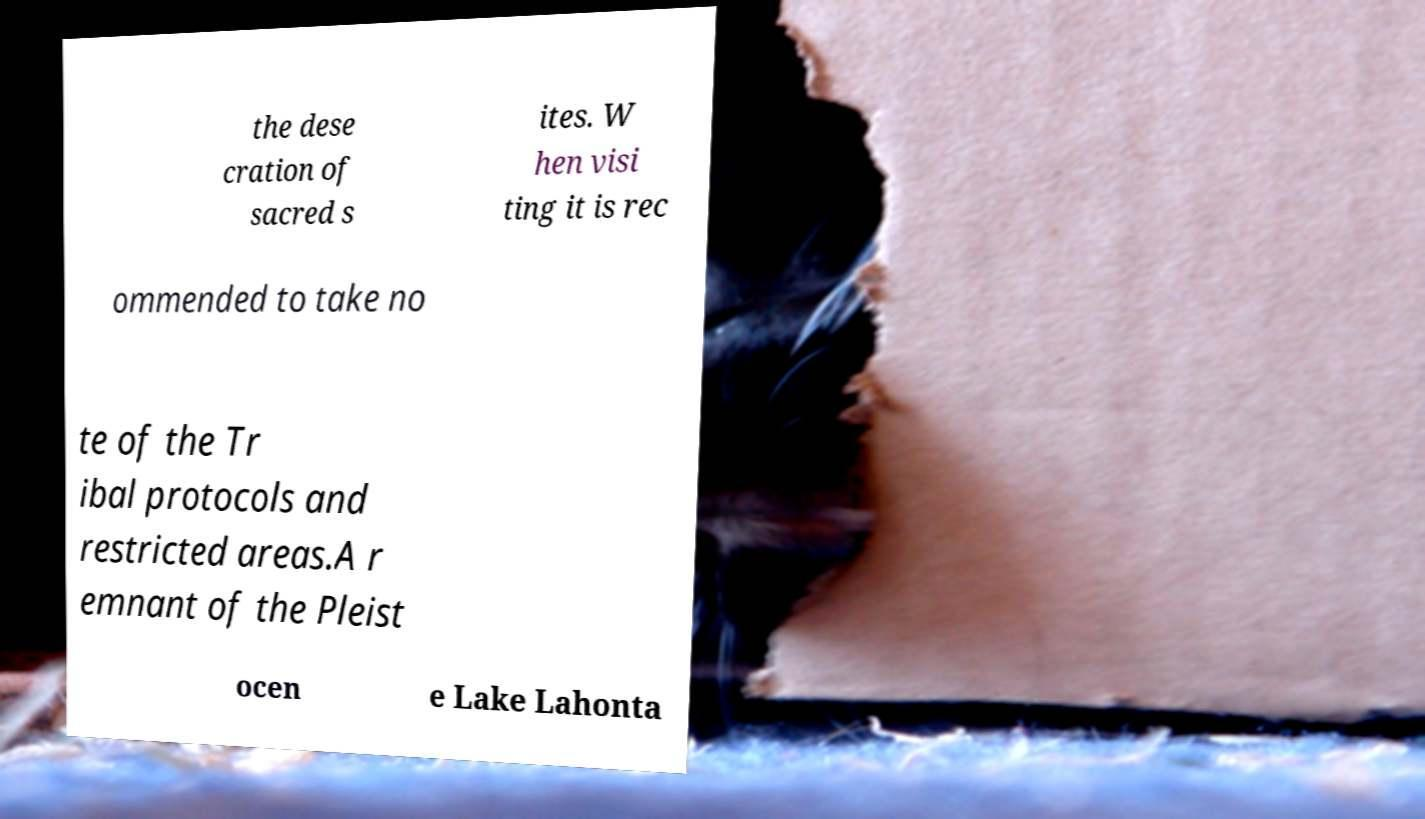Can you read and provide the text displayed in the image?This photo seems to have some interesting text. Can you extract and type it out for me? the dese cration of sacred s ites. W hen visi ting it is rec ommended to take no te of the Tr ibal protocols and restricted areas.A r emnant of the Pleist ocen e Lake Lahonta 